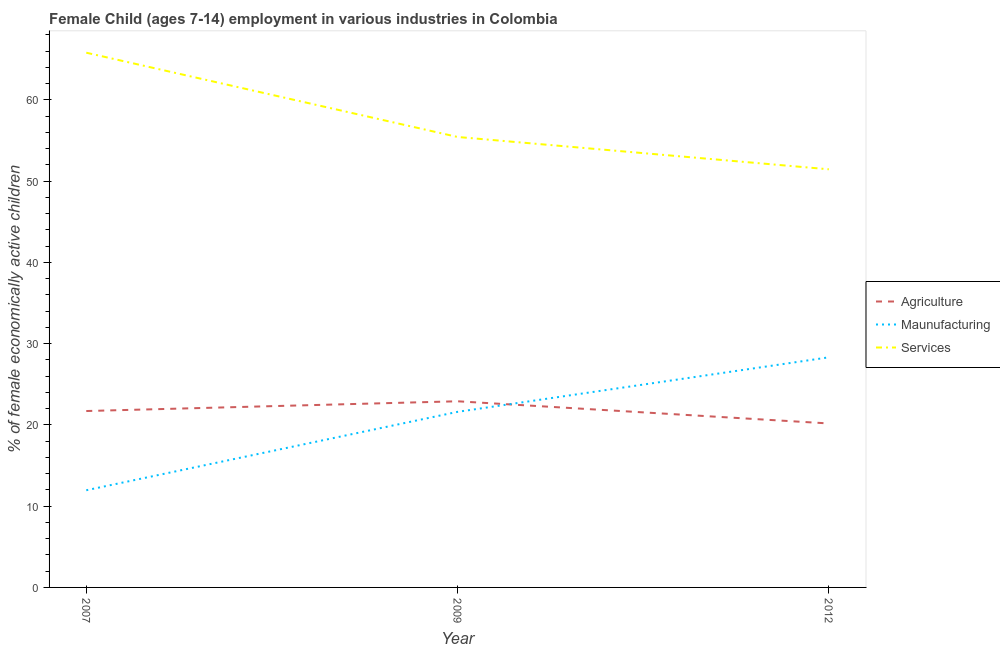Does the line corresponding to percentage of economically active children in services intersect with the line corresponding to percentage of economically active children in manufacturing?
Ensure brevity in your answer.  No. Is the number of lines equal to the number of legend labels?
Give a very brief answer. Yes. What is the percentage of economically active children in manufacturing in 2009?
Keep it short and to the point. 21.61. Across all years, what is the maximum percentage of economically active children in services?
Your answer should be very brief. 65.81. Across all years, what is the minimum percentage of economically active children in agriculture?
Make the answer very short. 20.18. In which year was the percentage of economically active children in manufacturing minimum?
Your answer should be compact. 2007. What is the total percentage of economically active children in manufacturing in the graph?
Your response must be concise. 61.89. What is the difference between the percentage of economically active children in manufacturing in 2007 and that in 2012?
Offer a terse response. -16.36. What is the difference between the percentage of economically active children in manufacturing in 2007 and the percentage of economically active children in agriculture in 2012?
Ensure brevity in your answer.  -8.22. What is the average percentage of economically active children in services per year?
Your answer should be very brief. 57.57. In the year 2009, what is the difference between the percentage of economically active children in services and percentage of economically active children in agriculture?
Your response must be concise. 32.53. In how many years, is the percentage of economically active children in manufacturing greater than 40 %?
Your response must be concise. 0. What is the ratio of the percentage of economically active children in agriculture in 2007 to that in 2009?
Your response must be concise. 0.95. Is the percentage of economically active children in manufacturing in 2007 less than that in 2009?
Ensure brevity in your answer.  Yes. What is the difference between the highest and the second highest percentage of economically active children in services?
Ensure brevity in your answer.  10.37. What is the difference between the highest and the lowest percentage of economically active children in manufacturing?
Offer a terse response. 16.36. Is the sum of the percentage of economically active children in manufacturing in 2007 and 2009 greater than the maximum percentage of economically active children in services across all years?
Provide a short and direct response. No. Is it the case that in every year, the sum of the percentage of economically active children in agriculture and percentage of economically active children in manufacturing is greater than the percentage of economically active children in services?
Your response must be concise. No. How many lines are there?
Your answer should be very brief. 3. How many years are there in the graph?
Give a very brief answer. 3. What is the difference between two consecutive major ticks on the Y-axis?
Give a very brief answer. 10. Does the graph contain any zero values?
Provide a succinct answer. No. How many legend labels are there?
Your answer should be compact. 3. How are the legend labels stacked?
Offer a terse response. Vertical. What is the title of the graph?
Your response must be concise. Female Child (ages 7-14) employment in various industries in Colombia. Does "Natural Gas" appear as one of the legend labels in the graph?
Your answer should be very brief. No. What is the label or title of the Y-axis?
Offer a very short reply. % of female economically active children. What is the % of female economically active children in Agriculture in 2007?
Keep it short and to the point. 21.71. What is the % of female economically active children in Maunufacturing in 2007?
Provide a succinct answer. 11.96. What is the % of female economically active children in Services in 2007?
Keep it short and to the point. 65.81. What is the % of female economically active children of Agriculture in 2009?
Your answer should be very brief. 22.91. What is the % of female economically active children of Maunufacturing in 2009?
Give a very brief answer. 21.61. What is the % of female economically active children of Services in 2009?
Your response must be concise. 55.44. What is the % of female economically active children of Agriculture in 2012?
Give a very brief answer. 20.18. What is the % of female economically active children of Maunufacturing in 2012?
Ensure brevity in your answer.  28.32. What is the % of female economically active children of Services in 2012?
Provide a succinct answer. 51.46. Across all years, what is the maximum % of female economically active children in Agriculture?
Provide a succinct answer. 22.91. Across all years, what is the maximum % of female economically active children of Maunufacturing?
Your answer should be compact. 28.32. Across all years, what is the maximum % of female economically active children in Services?
Your answer should be very brief. 65.81. Across all years, what is the minimum % of female economically active children in Agriculture?
Give a very brief answer. 20.18. Across all years, what is the minimum % of female economically active children in Maunufacturing?
Make the answer very short. 11.96. Across all years, what is the minimum % of female economically active children in Services?
Keep it short and to the point. 51.46. What is the total % of female economically active children of Agriculture in the graph?
Give a very brief answer. 64.8. What is the total % of female economically active children in Maunufacturing in the graph?
Your answer should be compact. 61.89. What is the total % of female economically active children of Services in the graph?
Keep it short and to the point. 172.71. What is the difference between the % of female economically active children of Agriculture in 2007 and that in 2009?
Ensure brevity in your answer.  -1.2. What is the difference between the % of female economically active children in Maunufacturing in 2007 and that in 2009?
Provide a short and direct response. -9.65. What is the difference between the % of female economically active children of Services in 2007 and that in 2009?
Provide a short and direct response. 10.37. What is the difference between the % of female economically active children of Agriculture in 2007 and that in 2012?
Keep it short and to the point. 1.53. What is the difference between the % of female economically active children in Maunufacturing in 2007 and that in 2012?
Your answer should be compact. -16.36. What is the difference between the % of female economically active children of Services in 2007 and that in 2012?
Keep it short and to the point. 14.35. What is the difference between the % of female economically active children of Agriculture in 2009 and that in 2012?
Offer a very short reply. 2.73. What is the difference between the % of female economically active children of Maunufacturing in 2009 and that in 2012?
Make the answer very short. -6.71. What is the difference between the % of female economically active children of Services in 2009 and that in 2012?
Ensure brevity in your answer.  3.98. What is the difference between the % of female economically active children in Agriculture in 2007 and the % of female economically active children in Maunufacturing in 2009?
Ensure brevity in your answer.  0.1. What is the difference between the % of female economically active children of Agriculture in 2007 and the % of female economically active children of Services in 2009?
Provide a short and direct response. -33.73. What is the difference between the % of female economically active children in Maunufacturing in 2007 and the % of female economically active children in Services in 2009?
Offer a terse response. -43.48. What is the difference between the % of female economically active children in Agriculture in 2007 and the % of female economically active children in Maunufacturing in 2012?
Ensure brevity in your answer.  -6.61. What is the difference between the % of female economically active children in Agriculture in 2007 and the % of female economically active children in Services in 2012?
Keep it short and to the point. -29.75. What is the difference between the % of female economically active children in Maunufacturing in 2007 and the % of female economically active children in Services in 2012?
Ensure brevity in your answer.  -39.5. What is the difference between the % of female economically active children of Agriculture in 2009 and the % of female economically active children of Maunufacturing in 2012?
Your answer should be very brief. -5.41. What is the difference between the % of female economically active children of Agriculture in 2009 and the % of female economically active children of Services in 2012?
Your response must be concise. -28.55. What is the difference between the % of female economically active children of Maunufacturing in 2009 and the % of female economically active children of Services in 2012?
Offer a very short reply. -29.85. What is the average % of female economically active children of Agriculture per year?
Give a very brief answer. 21.6. What is the average % of female economically active children in Maunufacturing per year?
Give a very brief answer. 20.63. What is the average % of female economically active children of Services per year?
Offer a terse response. 57.57. In the year 2007, what is the difference between the % of female economically active children of Agriculture and % of female economically active children of Maunufacturing?
Ensure brevity in your answer.  9.75. In the year 2007, what is the difference between the % of female economically active children in Agriculture and % of female economically active children in Services?
Keep it short and to the point. -44.1. In the year 2007, what is the difference between the % of female economically active children in Maunufacturing and % of female economically active children in Services?
Offer a terse response. -53.85. In the year 2009, what is the difference between the % of female economically active children of Agriculture and % of female economically active children of Maunufacturing?
Ensure brevity in your answer.  1.3. In the year 2009, what is the difference between the % of female economically active children of Agriculture and % of female economically active children of Services?
Offer a very short reply. -32.53. In the year 2009, what is the difference between the % of female economically active children of Maunufacturing and % of female economically active children of Services?
Your answer should be very brief. -33.83. In the year 2012, what is the difference between the % of female economically active children of Agriculture and % of female economically active children of Maunufacturing?
Offer a terse response. -8.14. In the year 2012, what is the difference between the % of female economically active children of Agriculture and % of female economically active children of Services?
Your response must be concise. -31.28. In the year 2012, what is the difference between the % of female economically active children of Maunufacturing and % of female economically active children of Services?
Your answer should be compact. -23.14. What is the ratio of the % of female economically active children of Agriculture in 2007 to that in 2009?
Your answer should be very brief. 0.95. What is the ratio of the % of female economically active children in Maunufacturing in 2007 to that in 2009?
Your response must be concise. 0.55. What is the ratio of the % of female economically active children of Services in 2007 to that in 2009?
Your answer should be very brief. 1.19. What is the ratio of the % of female economically active children in Agriculture in 2007 to that in 2012?
Keep it short and to the point. 1.08. What is the ratio of the % of female economically active children of Maunufacturing in 2007 to that in 2012?
Your answer should be compact. 0.42. What is the ratio of the % of female economically active children in Services in 2007 to that in 2012?
Make the answer very short. 1.28. What is the ratio of the % of female economically active children of Agriculture in 2009 to that in 2012?
Ensure brevity in your answer.  1.14. What is the ratio of the % of female economically active children of Maunufacturing in 2009 to that in 2012?
Offer a very short reply. 0.76. What is the ratio of the % of female economically active children in Services in 2009 to that in 2012?
Keep it short and to the point. 1.08. What is the difference between the highest and the second highest % of female economically active children of Maunufacturing?
Make the answer very short. 6.71. What is the difference between the highest and the second highest % of female economically active children of Services?
Your answer should be very brief. 10.37. What is the difference between the highest and the lowest % of female economically active children in Agriculture?
Make the answer very short. 2.73. What is the difference between the highest and the lowest % of female economically active children in Maunufacturing?
Provide a short and direct response. 16.36. What is the difference between the highest and the lowest % of female economically active children in Services?
Make the answer very short. 14.35. 